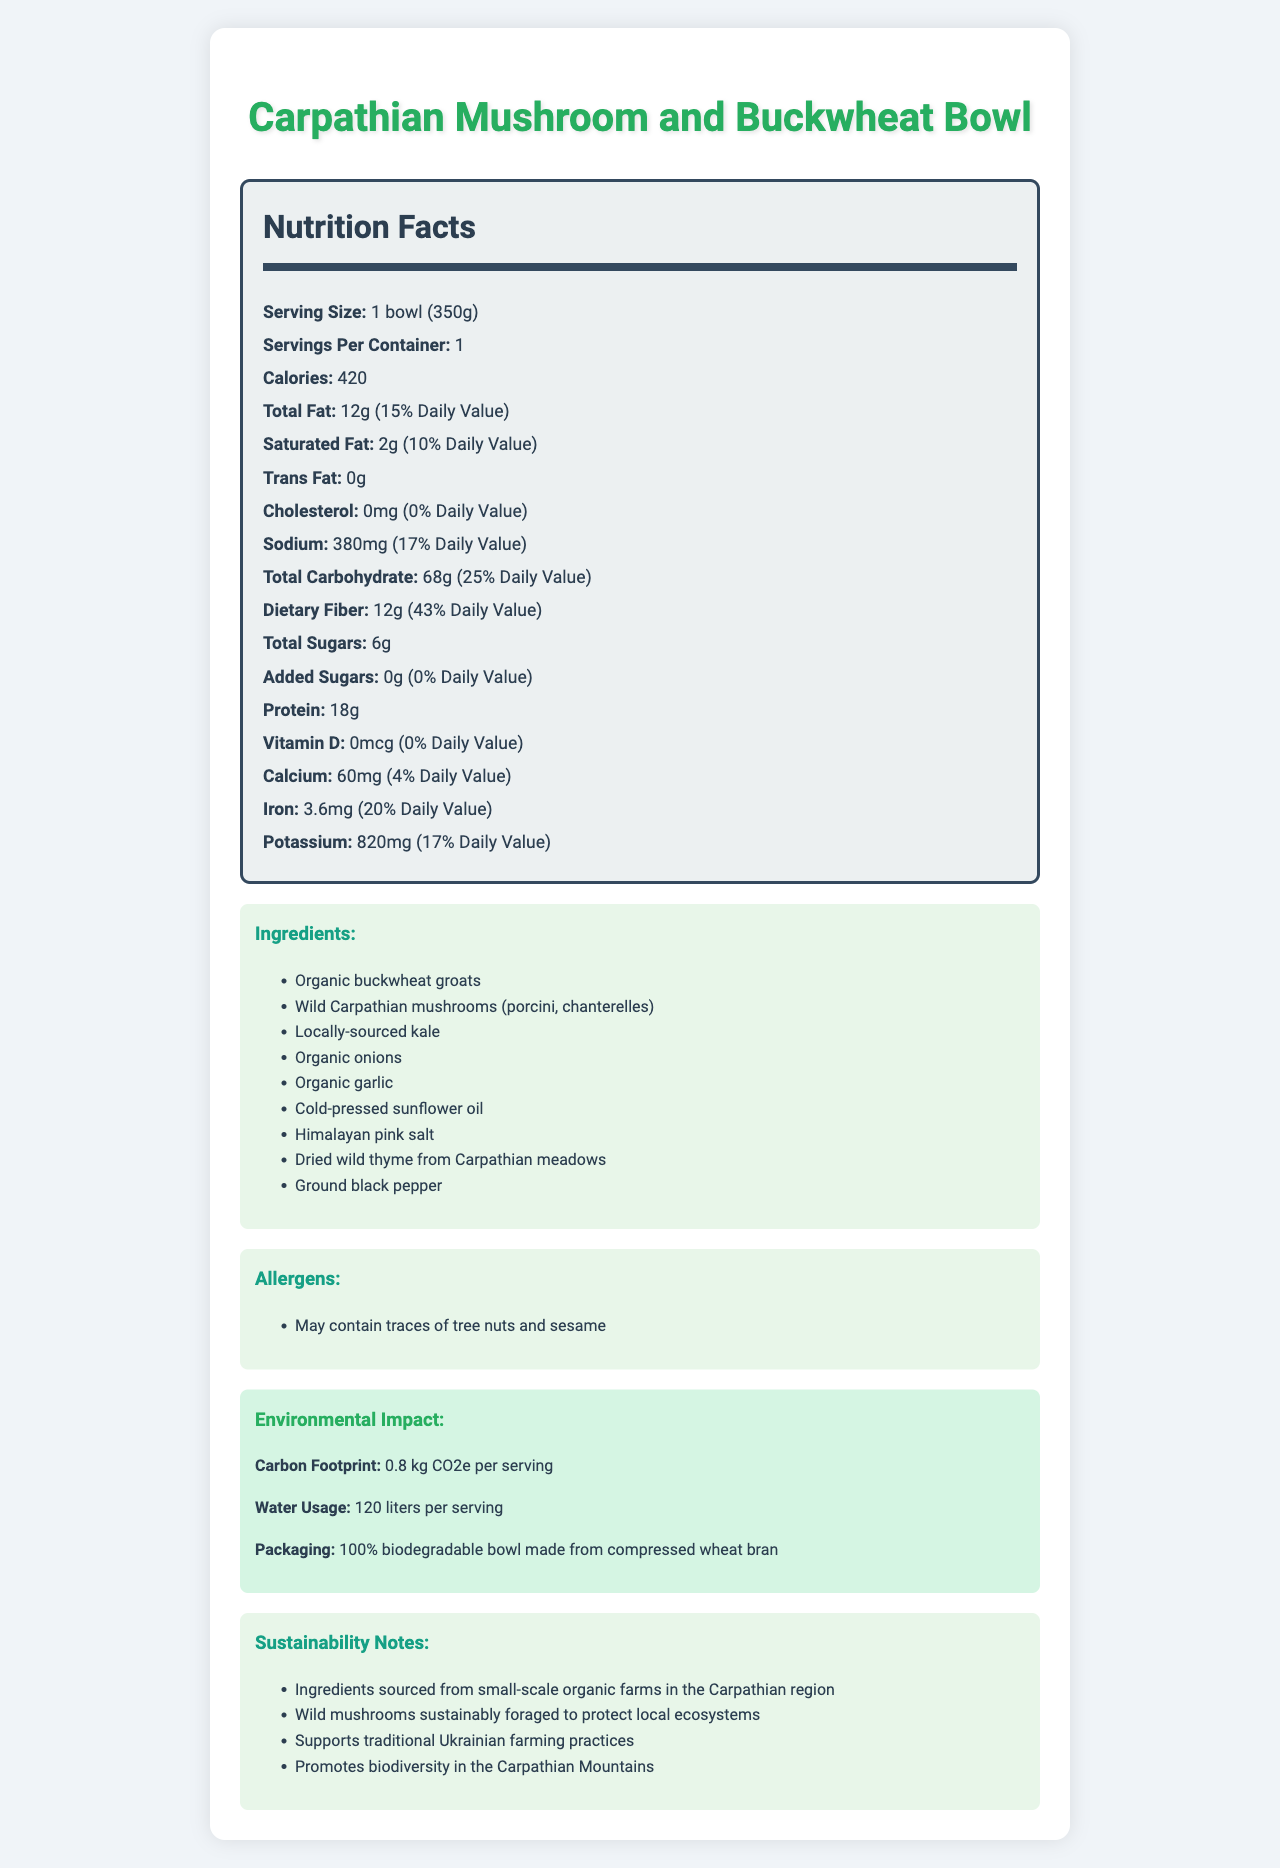what is the serving size for the Carpathian Mushroom and Buckwheat Bowl? The serving size is clearly mentioned at the beginning of the nutrition label as "1 bowl (350g)."
Answer: 1 bowl (350g) how many calories are in one serving of the meal? The nutrition label states that the bowl contains 420 calories per serving.
Answer: 420 what is the amount of protein in a single serving? The amount of protein is specified as 18g on the nutrition label.
Answer: 18g which ingredient makes up most of the dietary fiber content? The document lists all the ingredients but does not specify which one contributes most to the dietary fiber.
Answer: Not enough information does the meal contain any cholesterol? The nutrition label shows that the cholesterol amount is 0mg, indicating that there is no cholesterol in the meal.
Answer: No how many grams of saturated fat are in the bowl? The label states that there are 2g of saturated fat per serving.
Answer: 2g what are the total carbohydrates percentage daily value based on the document? The total carbohydrate percentage daily value provided is 25%.
Answer: 25% how much sodium is in the meal? The nutrition label lists sodium content as 380mg.
Answer: 380mg is there any added sugar in the Carpathian Mushroom and Buckwheat Bowl? The label shows 0g of added sugars, meaning there are no added sugars in the meal.
Answer: No which of the following is a main ingredient in the meal? A. Broccoli B. Organic buckwheat groats C. Chicken The ingredient list includes "Organic buckwheat groats" but not the other two options.
Answer: B how much iron does the meal contain in terms of daily value percentage? A. 10% B. 20% C. 15% D. 25% The document states that the meal contains 3.6mg of iron, which is 20% of the daily value.
Answer: B is the packaging of the meal environmentally sustainable? The document states that the packaging is 100% biodegradable and made from compressed wheat bran.
Answer: Yes summarize the main idea of the document. The document provides comprehensive nutritional information, lists all the ingredients, mentions allergens, describes environmental impacts, and gives sustainability notes.
Answer: The Carpathian Mushroom and Buckwheat Bowl is a plant-based meal with a detailed nutritional profile, sustainable ingredients, and eco-friendly packaging that supports traditional Ukrainian farming practices. how is the wild mushroom foraging done sustainably? The document mentions that the wild mushrooms are sustainably foraged to protect local ecosystems, promoting biodiversity in the Carpathian Mountains.
Answer: Supports local ecosystems do wild mushrooms contribute to the total sugars in the meal? The document does not specify which ingredients contribute to the total sugars.
Answer: Cannot be determined is this meal suitable for someone with tree nut allergies? The allergen list includes a warning that the meal may contain traces of tree nuts.
Answer: Might contain traces of tree nuts 